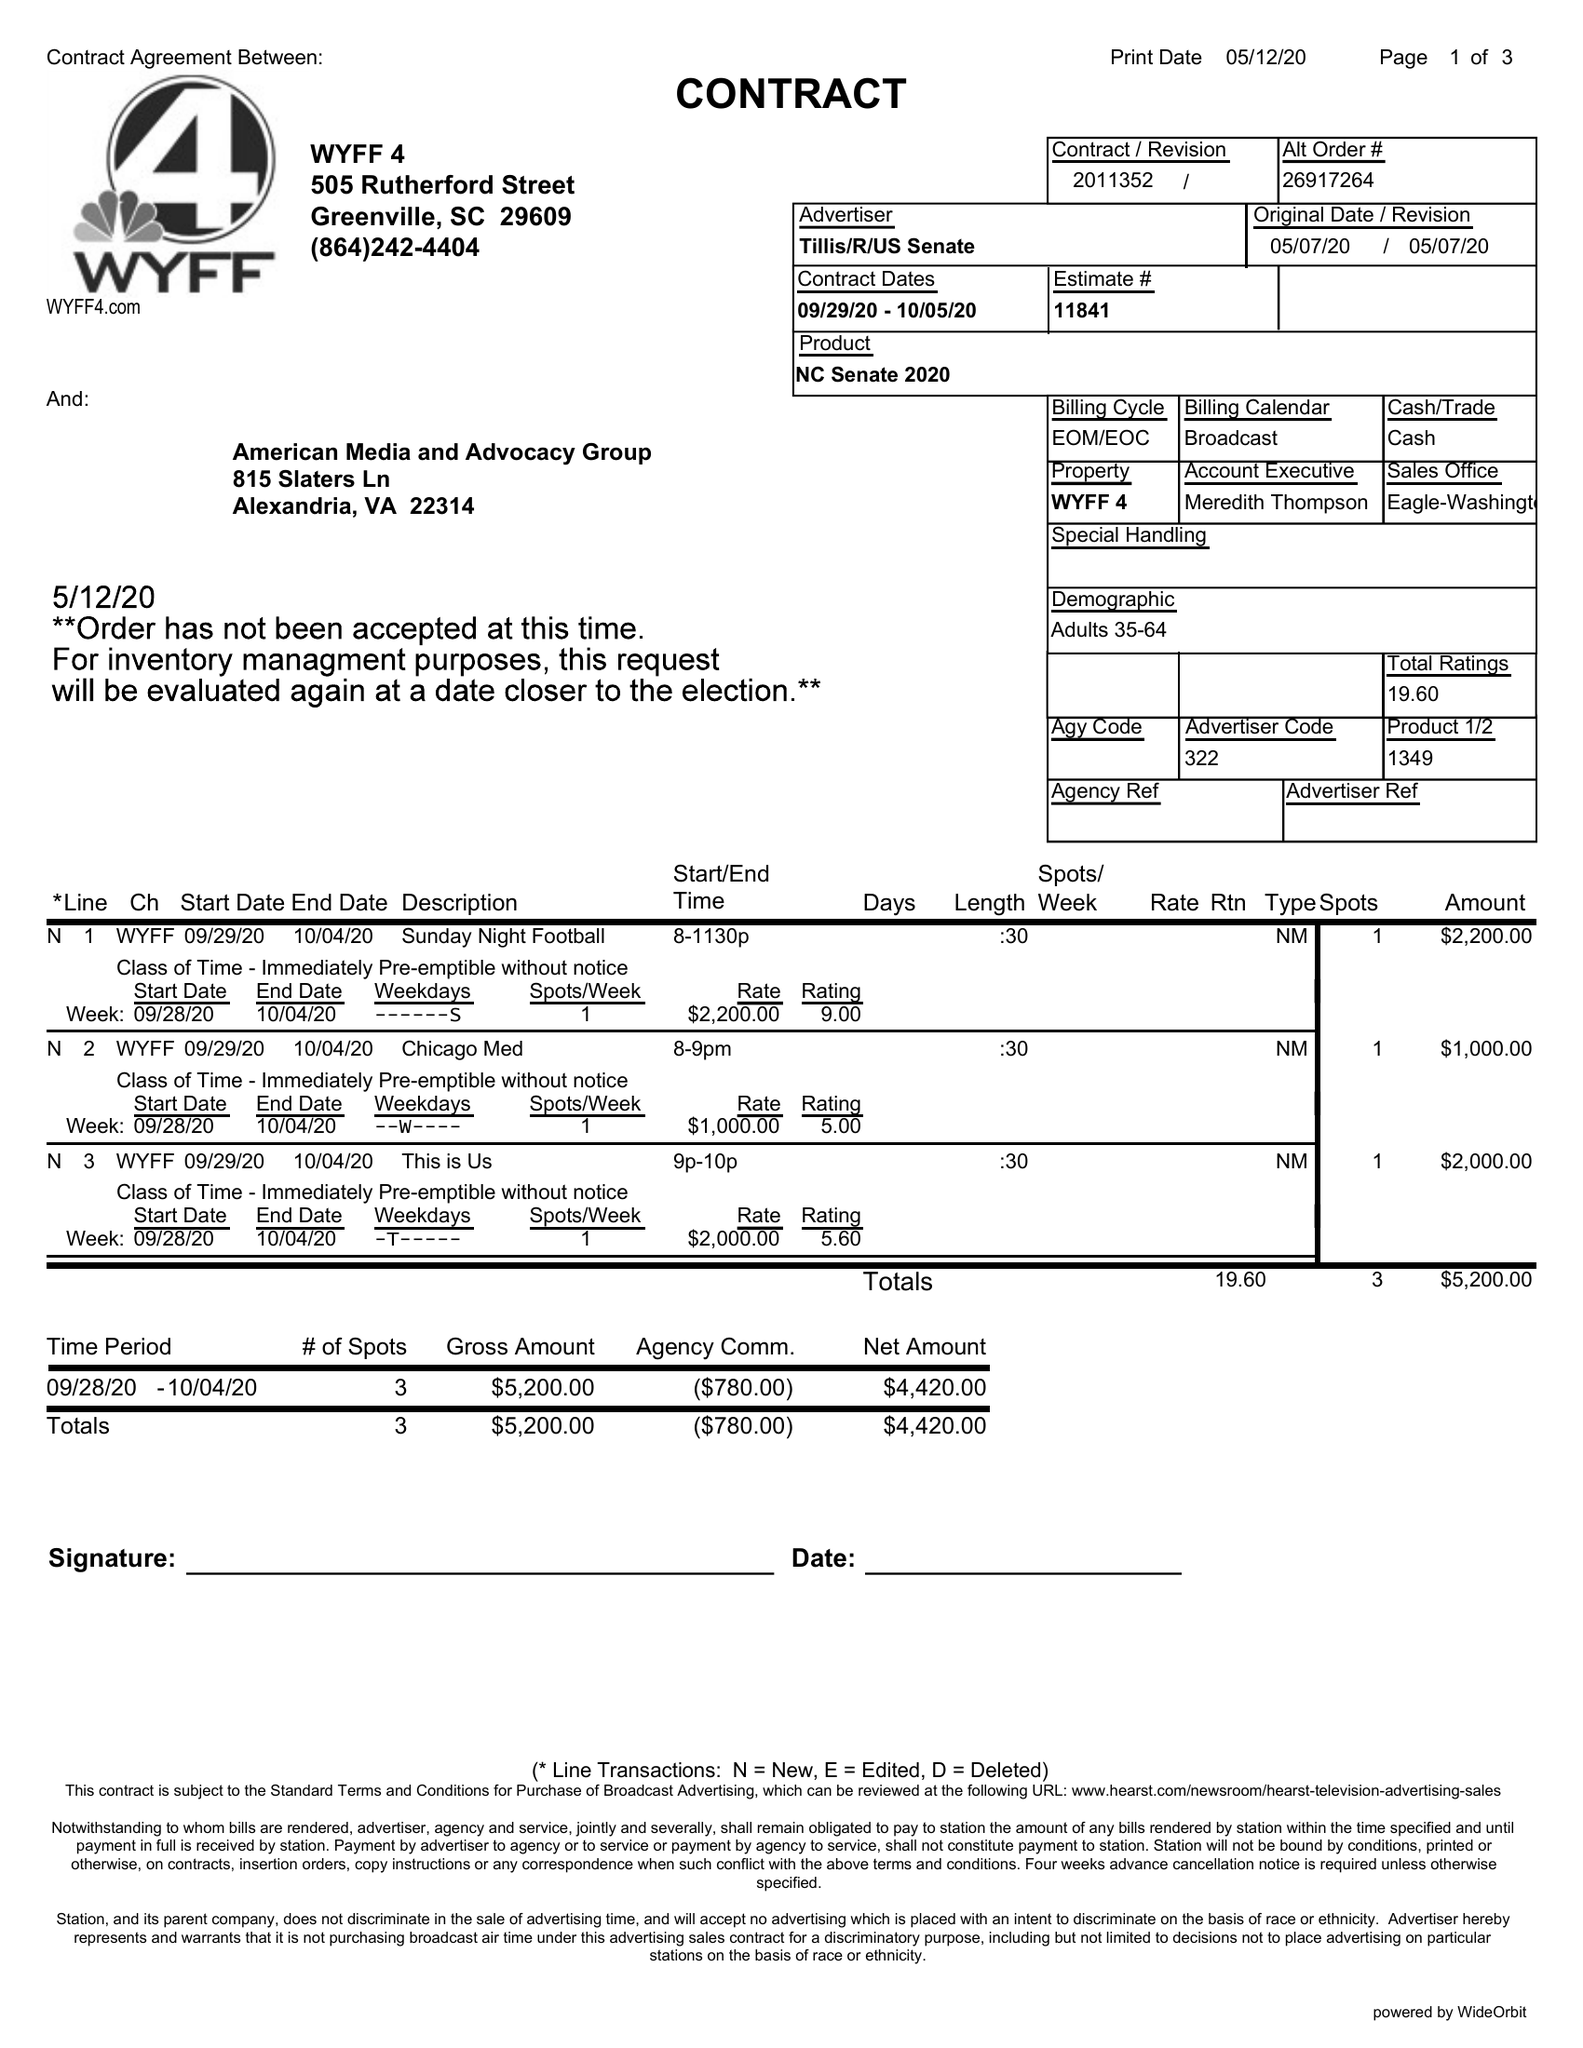What is the value for the flight_from?
Answer the question using a single word or phrase. 09/29/20 